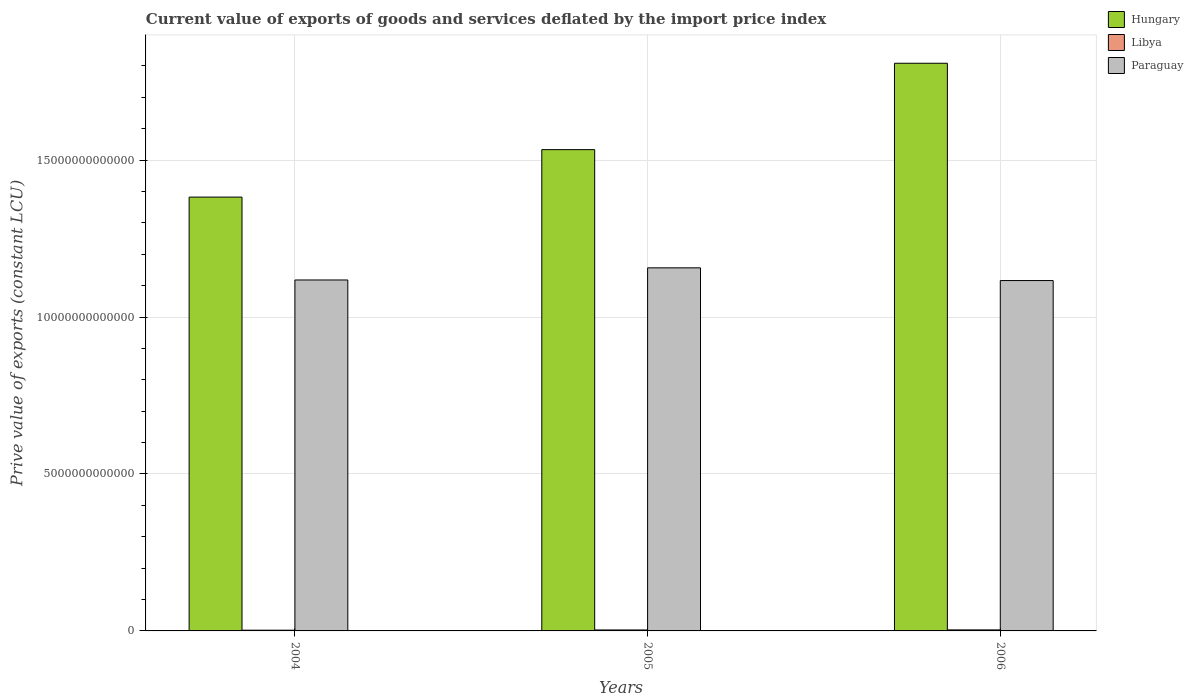How many groups of bars are there?
Your answer should be very brief. 3. Are the number of bars per tick equal to the number of legend labels?
Your answer should be very brief. Yes. How many bars are there on the 1st tick from the left?
Your response must be concise. 3. What is the label of the 3rd group of bars from the left?
Make the answer very short. 2006. In how many cases, is the number of bars for a given year not equal to the number of legend labels?
Your answer should be very brief. 0. What is the prive value of exports in Paraguay in 2006?
Your response must be concise. 1.12e+13. Across all years, what is the maximum prive value of exports in Hungary?
Your answer should be very brief. 1.81e+13. Across all years, what is the minimum prive value of exports in Paraguay?
Offer a terse response. 1.12e+13. What is the total prive value of exports in Hungary in the graph?
Your response must be concise. 4.72e+13. What is the difference between the prive value of exports in Paraguay in 2004 and that in 2005?
Make the answer very short. -3.87e+11. What is the difference between the prive value of exports in Paraguay in 2005 and the prive value of exports in Libya in 2004?
Give a very brief answer. 1.15e+13. What is the average prive value of exports in Paraguay per year?
Keep it short and to the point. 1.13e+13. In the year 2004, what is the difference between the prive value of exports in Libya and prive value of exports in Paraguay?
Make the answer very short. -1.12e+13. What is the ratio of the prive value of exports in Paraguay in 2004 to that in 2005?
Provide a succinct answer. 0.97. What is the difference between the highest and the second highest prive value of exports in Paraguay?
Your answer should be very brief. 3.87e+11. What is the difference between the highest and the lowest prive value of exports in Hungary?
Your answer should be very brief. 4.26e+12. In how many years, is the prive value of exports in Libya greater than the average prive value of exports in Libya taken over all years?
Offer a very short reply. 2. What does the 3rd bar from the left in 2004 represents?
Keep it short and to the point. Paraguay. What does the 2nd bar from the right in 2006 represents?
Keep it short and to the point. Libya. How many bars are there?
Keep it short and to the point. 9. What is the difference between two consecutive major ticks on the Y-axis?
Your response must be concise. 5.00e+12. Does the graph contain grids?
Offer a terse response. Yes. Where does the legend appear in the graph?
Offer a terse response. Top right. How many legend labels are there?
Your answer should be very brief. 3. What is the title of the graph?
Provide a short and direct response. Current value of exports of goods and services deflated by the import price index. Does "Curacao" appear as one of the legend labels in the graph?
Your response must be concise. No. What is the label or title of the X-axis?
Give a very brief answer. Years. What is the label or title of the Y-axis?
Your answer should be very brief. Prive value of exports (constant LCU). What is the Prive value of exports (constant LCU) in Hungary in 2004?
Make the answer very short. 1.38e+13. What is the Prive value of exports (constant LCU) of Libya in 2004?
Give a very brief answer. 2.31e+1. What is the Prive value of exports (constant LCU) in Paraguay in 2004?
Make the answer very short. 1.12e+13. What is the Prive value of exports (constant LCU) of Hungary in 2005?
Provide a short and direct response. 1.53e+13. What is the Prive value of exports (constant LCU) in Libya in 2005?
Offer a very short reply. 3.07e+1. What is the Prive value of exports (constant LCU) in Paraguay in 2005?
Your answer should be very brief. 1.16e+13. What is the Prive value of exports (constant LCU) of Hungary in 2006?
Your response must be concise. 1.81e+13. What is the Prive value of exports (constant LCU) in Libya in 2006?
Provide a short and direct response. 3.24e+1. What is the Prive value of exports (constant LCU) of Paraguay in 2006?
Offer a terse response. 1.12e+13. Across all years, what is the maximum Prive value of exports (constant LCU) of Hungary?
Give a very brief answer. 1.81e+13. Across all years, what is the maximum Prive value of exports (constant LCU) of Libya?
Ensure brevity in your answer.  3.24e+1. Across all years, what is the maximum Prive value of exports (constant LCU) in Paraguay?
Provide a succinct answer. 1.16e+13. Across all years, what is the minimum Prive value of exports (constant LCU) of Hungary?
Your answer should be very brief. 1.38e+13. Across all years, what is the minimum Prive value of exports (constant LCU) of Libya?
Your response must be concise. 2.31e+1. Across all years, what is the minimum Prive value of exports (constant LCU) of Paraguay?
Make the answer very short. 1.12e+13. What is the total Prive value of exports (constant LCU) in Hungary in the graph?
Your answer should be very brief. 4.72e+13. What is the total Prive value of exports (constant LCU) in Libya in the graph?
Your response must be concise. 8.62e+1. What is the total Prive value of exports (constant LCU) of Paraguay in the graph?
Ensure brevity in your answer.  3.39e+13. What is the difference between the Prive value of exports (constant LCU) in Hungary in 2004 and that in 2005?
Give a very brief answer. -1.51e+12. What is the difference between the Prive value of exports (constant LCU) of Libya in 2004 and that in 2005?
Your answer should be compact. -7.58e+09. What is the difference between the Prive value of exports (constant LCU) in Paraguay in 2004 and that in 2005?
Offer a very short reply. -3.87e+11. What is the difference between the Prive value of exports (constant LCU) of Hungary in 2004 and that in 2006?
Make the answer very short. -4.26e+12. What is the difference between the Prive value of exports (constant LCU) in Libya in 2004 and that in 2006?
Provide a short and direct response. -9.25e+09. What is the difference between the Prive value of exports (constant LCU) in Paraguay in 2004 and that in 2006?
Your response must be concise. 1.87e+1. What is the difference between the Prive value of exports (constant LCU) in Hungary in 2005 and that in 2006?
Ensure brevity in your answer.  -2.75e+12. What is the difference between the Prive value of exports (constant LCU) of Libya in 2005 and that in 2006?
Keep it short and to the point. -1.67e+09. What is the difference between the Prive value of exports (constant LCU) of Paraguay in 2005 and that in 2006?
Make the answer very short. 4.05e+11. What is the difference between the Prive value of exports (constant LCU) of Hungary in 2004 and the Prive value of exports (constant LCU) of Libya in 2005?
Give a very brief answer. 1.38e+13. What is the difference between the Prive value of exports (constant LCU) in Hungary in 2004 and the Prive value of exports (constant LCU) in Paraguay in 2005?
Offer a terse response. 2.25e+12. What is the difference between the Prive value of exports (constant LCU) in Libya in 2004 and the Prive value of exports (constant LCU) in Paraguay in 2005?
Provide a short and direct response. -1.15e+13. What is the difference between the Prive value of exports (constant LCU) of Hungary in 2004 and the Prive value of exports (constant LCU) of Libya in 2006?
Provide a succinct answer. 1.38e+13. What is the difference between the Prive value of exports (constant LCU) of Hungary in 2004 and the Prive value of exports (constant LCU) of Paraguay in 2006?
Ensure brevity in your answer.  2.66e+12. What is the difference between the Prive value of exports (constant LCU) of Libya in 2004 and the Prive value of exports (constant LCU) of Paraguay in 2006?
Provide a succinct answer. -1.11e+13. What is the difference between the Prive value of exports (constant LCU) in Hungary in 2005 and the Prive value of exports (constant LCU) in Libya in 2006?
Ensure brevity in your answer.  1.53e+13. What is the difference between the Prive value of exports (constant LCU) in Hungary in 2005 and the Prive value of exports (constant LCU) in Paraguay in 2006?
Your response must be concise. 4.17e+12. What is the difference between the Prive value of exports (constant LCU) of Libya in 2005 and the Prive value of exports (constant LCU) of Paraguay in 2006?
Give a very brief answer. -1.11e+13. What is the average Prive value of exports (constant LCU) in Hungary per year?
Your response must be concise. 1.57e+13. What is the average Prive value of exports (constant LCU) of Libya per year?
Provide a succinct answer. 2.87e+1. What is the average Prive value of exports (constant LCU) in Paraguay per year?
Your answer should be very brief. 1.13e+13. In the year 2004, what is the difference between the Prive value of exports (constant LCU) of Hungary and Prive value of exports (constant LCU) of Libya?
Make the answer very short. 1.38e+13. In the year 2004, what is the difference between the Prive value of exports (constant LCU) of Hungary and Prive value of exports (constant LCU) of Paraguay?
Offer a terse response. 2.64e+12. In the year 2004, what is the difference between the Prive value of exports (constant LCU) in Libya and Prive value of exports (constant LCU) in Paraguay?
Ensure brevity in your answer.  -1.12e+13. In the year 2005, what is the difference between the Prive value of exports (constant LCU) of Hungary and Prive value of exports (constant LCU) of Libya?
Offer a very short reply. 1.53e+13. In the year 2005, what is the difference between the Prive value of exports (constant LCU) in Hungary and Prive value of exports (constant LCU) in Paraguay?
Provide a short and direct response. 3.77e+12. In the year 2005, what is the difference between the Prive value of exports (constant LCU) in Libya and Prive value of exports (constant LCU) in Paraguay?
Make the answer very short. -1.15e+13. In the year 2006, what is the difference between the Prive value of exports (constant LCU) of Hungary and Prive value of exports (constant LCU) of Libya?
Provide a succinct answer. 1.81e+13. In the year 2006, what is the difference between the Prive value of exports (constant LCU) of Hungary and Prive value of exports (constant LCU) of Paraguay?
Offer a very short reply. 6.92e+12. In the year 2006, what is the difference between the Prive value of exports (constant LCU) in Libya and Prive value of exports (constant LCU) in Paraguay?
Ensure brevity in your answer.  -1.11e+13. What is the ratio of the Prive value of exports (constant LCU) in Hungary in 2004 to that in 2005?
Provide a succinct answer. 0.9. What is the ratio of the Prive value of exports (constant LCU) in Libya in 2004 to that in 2005?
Provide a succinct answer. 0.75. What is the ratio of the Prive value of exports (constant LCU) in Paraguay in 2004 to that in 2005?
Provide a succinct answer. 0.97. What is the ratio of the Prive value of exports (constant LCU) in Hungary in 2004 to that in 2006?
Provide a succinct answer. 0.76. What is the ratio of the Prive value of exports (constant LCU) of Libya in 2004 to that in 2006?
Offer a terse response. 0.71. What is the ratio of the Prive value of exports (constant LCU) in Paraguay in 2004 to that in 2006?
Provide a succinct answer. 1. What is the ratio of the Prive value of exports (constant LCU) of Hungary in 2005 to that in 2006?
Offer a very short reply. 0.85. What is the ratio of the Prive value of exports (constant LCU) in Libya in 2005 to that in 2006?
Offer a very short reply. 0.95. What is the ratio of the Prive value of exports (constant LCU) of Paraguay in 2005 to that in 2006?
Your answer should be very brief. 1.04. What is the difference between the highest and the second highest Prive value of exports (constant LCU) of Hungary?
Your answer should be compact. 2.75e+12. What is the difference between the highest and the second highest Prive value of exports (constant LCU) of Libya?
Make the answer very short. 1.67e+09. What is the difference between the highest and the second highest Prive value of exports (constant LCU) in Paraguay?
Ensure brevity in your answer.  3.87e+11. What is the difference between the highest and the lowest Prive value of exports (constant LCU) of Hungary?
Provide a succinct answer. 4.26e+12. What is the difference between the highest and the lowest Prive value of exports (constant LCU) of Libya?
Your answer should be compact. 9.25e+09. What is the difference between the highest and the lowest Prive value of exports (constant LCU) in Paraguay?
Provide a succinct answer. 4.05e+11. 